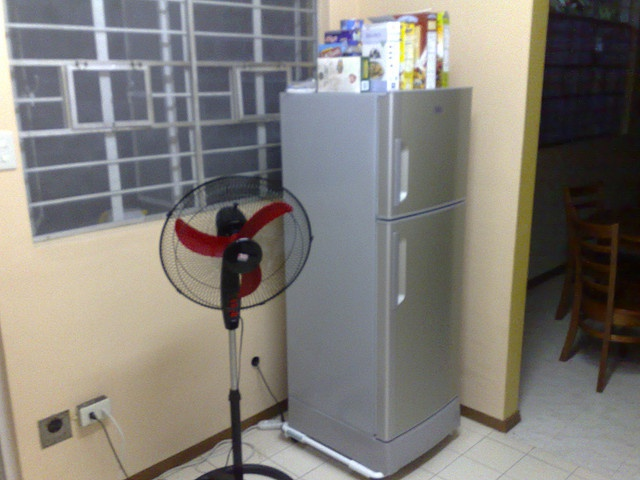Describe the objects in this image and their specific colors. I can see refrigerator in white and gray tones, chair in white, black, gray, maroon, and darkgreen tones, chair in black and white tones, and dining table in black, maroon, and white tones in this image. 